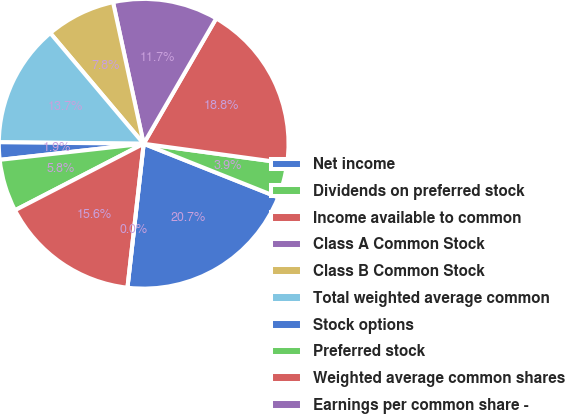Convert chart to OTSL. <chart><loc_0><loc_0><loc_500><loc_500><pie_chart><fcel>Net income<fcel>Dividends on preferred stock<fcel>Income available to common<fcel>Class A Common Stock<fcel>Class B Common Stock<fcel>Total weighted average common<fcel>Stock options<fcel>Preferred stock<fcel>Weighted average common shares<fcel>Earnings per common share -<nl><fcel>20.75%<fcel>3.88%<fcel>18.81%<fcel>11.74%<fcel>7.76%<fcel>13.68%<fcel>1.94%<fcel>5.82%<fcel>15.62%<fcel>0.0%<nl></chart> 